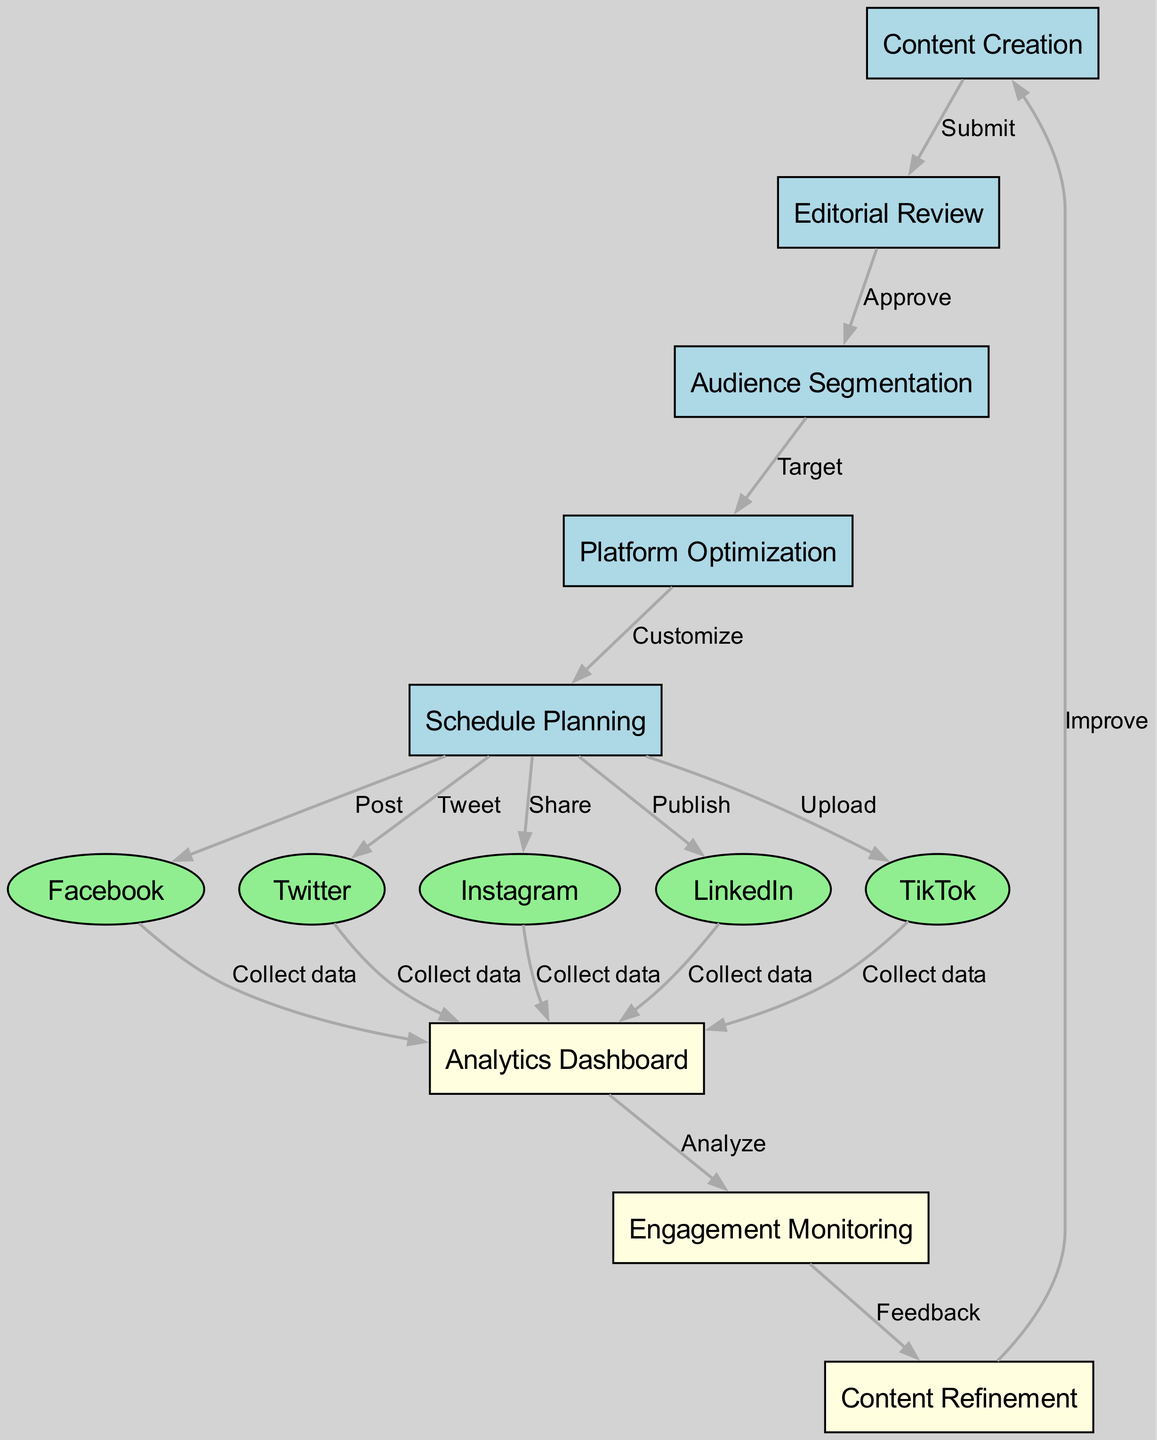What is the first step in the content distribution workflow? The first step as depicted in the diagram is "Content Creation," which is the starting point of the workflow. It initiates the process that flows towards editorial review and further steps.
Answer: Content Creation How many social media platforms are included in the diagram? The diagram indicates five social media platforms: Facebook, Twitter, Instagram, LinkedIn, and TikTok, each stemming from the "Schedule Planning" node.
Answer: Five What action is taken after Audience Segmentation? Following "Audience Segmentation," the next action is "Platform Optimization," indicating the workflow's progression towards optimizing content for targeted audiences.
Answer: Platform Optimization Which node collects data from Facebook? The node that collects data from Facebook, as per the diagram, is the "Analytics Dashboard." This shows that information gathered from Facebook feeds into this monitoring aspect of the workflow.
Answer: Analytics Dashboard What is the relationship between Engagement Monitoring and Content Refinement? The relationship is indicated by the edge labeled "Feedback," which shows that insights gained from "Engagement Monitoring" lead to "Content Refinement." This indicates an iterative process of improving content based on audience feedback.
Answer: Feedback How many edges are there in total in the diagram? The diagram consists of sixteen edges that represent the relationships and actions between nodes, illustrating the entire workflow of content distribution.
Answer: Sixteen What happens after the Scheduling Planning step? Following the "Schedule Planning" step, the content is distributed to various platforms such as Facebook, Twitter, Instagram, LinkedIn, and TikTok, showcasing the execution phase of the workflow.
Answer: Post What action follows after the Analytics Dashboard? The action that follows is "Engagement Monitoring," which is the next step where data analyzed on the dashboard is utilized to monitor audience interactions.
Answer: Engagement Monitoring What is the final step in the content distribution workflow? The final step in the workflow is "Content Creation," as the cycle closes back with improvements based on feedback, thus perpetuating the content generation process.
Answer: Content Creation 